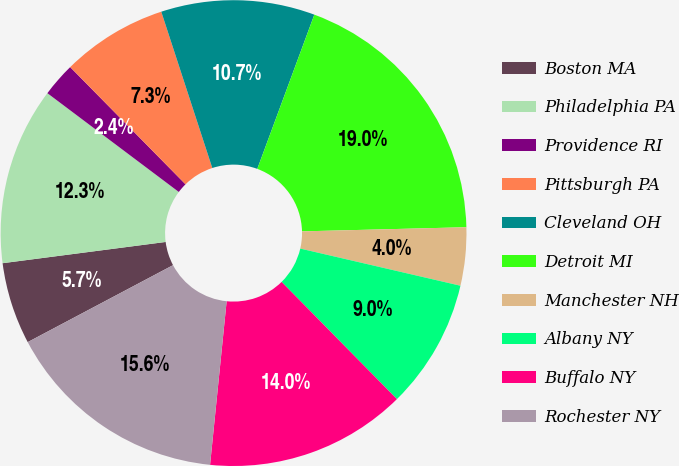<chart> <loc_0><loc_0><loc_500><loc_500><pie_chart><fcel>Boston MA<fcel>Philadelphia PA<fcel>Providence RI<fcel>Pittsburgh PA<fcel>Cleveland OH<fcel>Detroit MI<fcel>Manchester NH<fcel>Albany NY<fcel>Buffalo NY<fcel>Rochester NY<nl><fcel>5.69%<fcel>12.32%<fcel>2.37%<fcel>7.35%<fcel>10.66%<fcel>18.96%<fcel>4.03%<fcel>9.0%<fcel>13.98%<fcel>15.64%<nl></chart> 